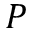Convert formula to latex. <formula><loc_0><loc_0><loc_500><loc_500>P</formula> 